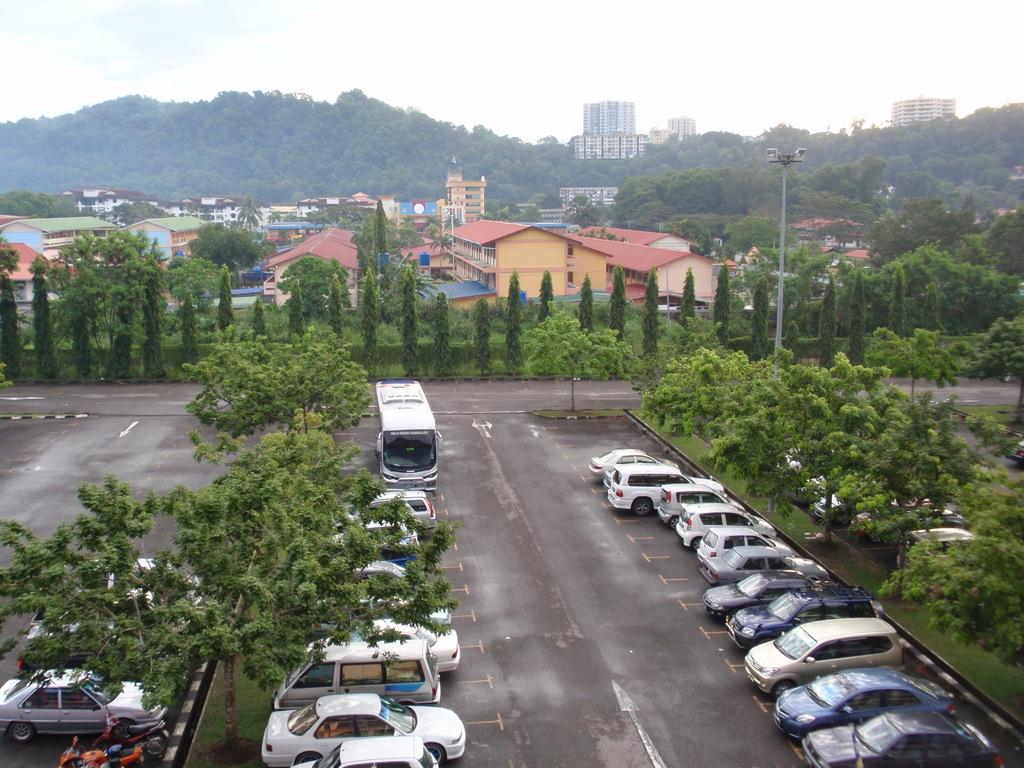What type of natural elements can be seen in the image? There are trees in the image. What type of man-made structures are visible in the image? There are houses in the image. What type of geographical feature can be seen in the image? There are mountains in the image. What type of lighting is present in the image? There are lamp posts in the image. What type of vehicles can be seen in the image? There are parked cars in the image. What type of locket is the dad wearing in the image? There is no dad or locket present in the image. What type of sign can be seen directing traffic in the image? There is no sign present in the image. 